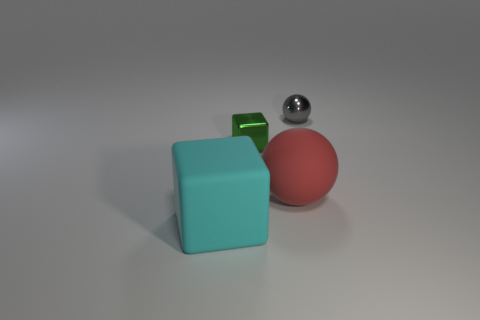How do the colors of the objects contrast with each other? The objects exhibit a vibrant contrast in colors, with the matte red sphere, the teal cube, and the small, reflective green cube each standing out distinctly against the neutral background. 